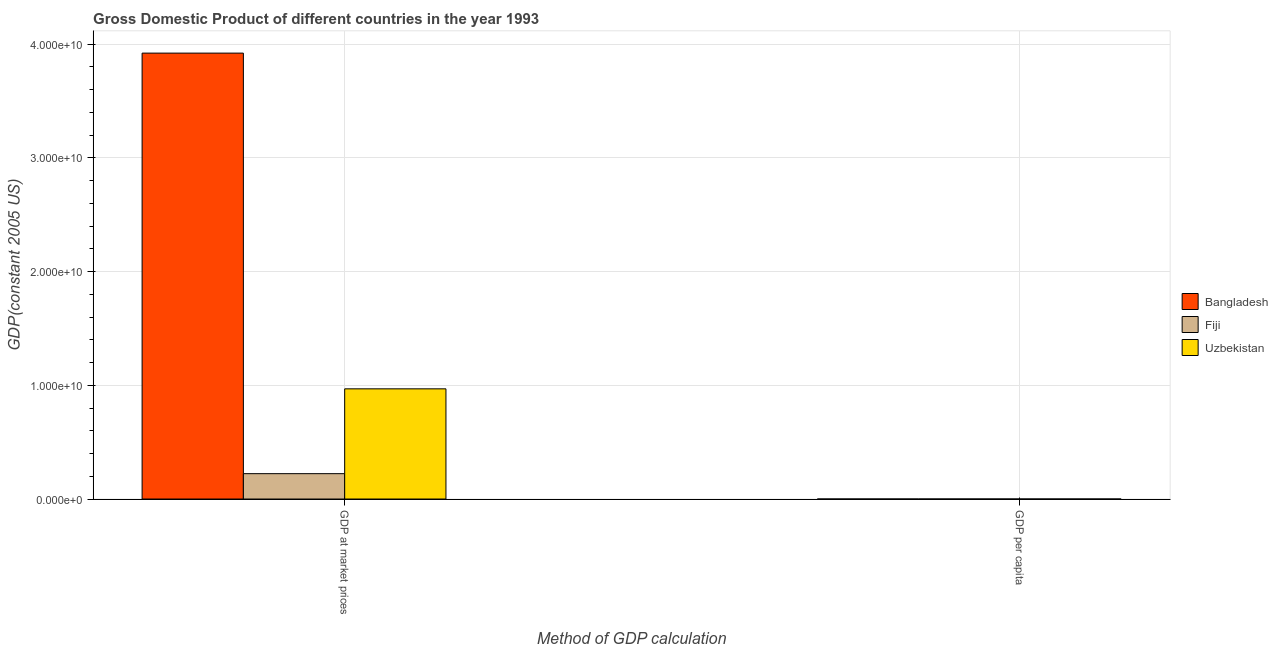How many groups of bars are there?
Your answer should be very brief. 2. How many bars are there on the 2nd tick from the left?
Your answer should be very brief. 3. What is the label of the 1st group of bars from the left?
Your answer should be very brief. GDP at market prices. What is the gdp at market prices in Uzbekistan?
Ensure brevity in your answer.  9.69e+09. Across all countries, what is the maximum gdp at market prices?
Give a very brief answer. 3.92e+1. Across all countries, what is the minimum gdp per capita?
Make the answer very short. 345.56. In which country was the gdp per capita maximum?
Make the answer very short. Fiji. In which country was the gdp at market prices minimum?
Ensure brevity in your answer.  Fiji. What is the total gdp per capita in the graph?
Make the answer very short. 3740.01. What is the difference between the gdp at market prices in Bangladesh and that in Fiji?
Offer a terse response. 3.70e+1. What is the difference between the gdp at market prices in Fiji and the gdp per capita in Uzbekistan?
Your answer should be compact. 2.23e+09. What is the average gdp at market prices per country?
Your response must be concise. 1.70e+1. What is the difference between the gdp at market prices and gdp per capita in Fiji?
Give a very brief answer. 2.23e+09. What is the ratio of the gdp per capita in Fiji to that in Bangladesh?
Provide a succinct answer. 8.55. Is the gdp at market prices in Bangladesh less than that in Fiji?
Your response must be concise. No. What does the 1st bar from the left in GDP at market prices represents?
Make the answer very short. Bangladesh. What does the 2nd bar from the right in GDP at market prices represents?
Keep it short and to the point. Fiji. How many bars are there?
Provide a short and direct response. 6. Does the graph contain any zero values?
Keep it short and to the point. No. How are the legend labels stacked?
Keep it short and to the point. Vertical. What is the title of the graph?
Offer a very short reply. Gross Domestic Product of different countries in the year 1993. Does "Ireland" appear as one of the legend labels in the graph?
Your answer should be compact. No. What is the label or title of the X-axis?
Offer a very short reply. Method of GDP calculation. What is the label or title of the Y-axis?
Offer a very short reply. GDP(constant 2005 US). What is the GDP(constant 2005 US) of Bangladesh in GDP at market prices?
Your answer should be very brief. 3.92e+1. What is the GDP(constant 2005 US) of Fiji in GDP at market prices?
Keep it short and to the point. 2.23e+09. What is the GDP(constant 2005 US) of Uzbekistan in GDP at market prices?
Provide a succinct answer. 9.69e+09. What is the GDP(constant 2005 US) in Bangladesh in GDP per capita?
Keep it short and to the point. 345.56. What is the GDP(constant 2005 US) in Fiji in GDP per capita?
Give a very brief answer. 2952.94. What is the GDP(constant 2005 US) of Uzbekistan in GDP per capita?
Your answer should be compact. 441.5. Across all Method of GDP calculation, what is the maximum GDP(constant 2005 US) of Bangladesh?
Your response must be concise. 3.92e+1. Across all Method of GDP calculation, what is the maximum GDP(constant 2005 US) in Fiji?
Offer a very short reply. 2.23e+09. Across all Method of GDP calculation, what is the maximum GDP(constant 2005 US) in Uzbekistan?
Your response must be concise. 9.69e+09. Across all Method of GDP calculation, what is the minimum GDP(constant 2005 US) of Bangladesh?
Your response must be concise. 345.56. Across all Method of GDP calculation, what is the minimum GDP(constant 2005 US) of Fiji?
Your answer should be very brief. 2952.94. Across all Method of GDP calculation, what is the minimum GDP(constant 2005 US) in Uzbekistan?
Ensure brevity in your answer.  441.5. What is the total GDP(constant 2005 US) of Bangladesh in the graph?
Your response must be concise. 3.92e+1. What is the total GDP(constant 2005 US) of Fiji in the graph?
Your response must be concise. 2.23e+09. What is the total GDP(constant 2005 US) of Uzbekistan in the graph?
Ensure brevity in your answer.  9.69e+09. What is the difference between the GDP(constant 2005 US) in Bangladesh in GDP at market prices and that in GDP per capita?
Offer a terse response. 3.92e+1. What is the difference between the GDP(constant 2005 US) of Fiji in GDP at market prices and that in GDP per capita?
Your answer should be compact. 2.23e+09. What is the difference between the GDP(constant 2005 US) of Uzbekistan in GDP at market prices and that in GDP per capita?
Ensure brevity in your answer.  9.69e+09. What is the difference between the GDP(constant 2005 US) of Bangladesh in GDP at market prices and the GDP(constant 2005 US) of Fiji in GDP per capita?
Keep it short and to the point. 3.92e+1. What is the difference between the GDP(constant 2005 US) in Bangladesh in GDP at market prices and the GDP(constant 2005 US) in Uzbekistan in GDP per capita?
Provide a short and direct response. 3.92e+1. What is the difference between the GDP(constant 2005 US) in Fiji in GDP at market prices and the GDP(constant 2005 US) in Uzbekistan in GDP per capita?
Offer a terse response. 2.23e+09. What is the average GDP(constant 2005 US) in Bangladesh per Method of GDP calculation?
Make the answer very short. 1.96e+1. What is the average GDP(constant 2005 US) in Fiji per Method of GDP calculation?
Keep it short and to the point. 1.11e+09. What is the average GDP(constant 2005 US) of Uzbekistan per Method of GDP calculation?
Offer a very short reply. 4.84e+09. What is the difference between the GDP(constant 2005 US) in Bangladesh and GDP(constant 2005 US) in Fiji in GDP at market prices?
Your answer should be compact. 3.70e+1. What is the difference between the GDP(constant 2005 US) of Bangladesh and GDP(constant 2005 US) of Uzbekistan in GDP at market prices?
Offer a very short reply. 2.95e+1. What is the difference between the GDP(constant 2005 US) in Fiji and GDP(constant 2005 US) in Uzbekistan in GDP at market prices?
Your response must be concise. -7.46e+09. What is the difference between the GDP(constant 2005 US) of Bangladesh and GDP(constant 2005 US) of Fiji in GDP per capita?
Your answer should be very brief. -2607.38. What is the difference between the GDP(constant 2005 US) of Bangladesh and GDP(constant 2005 US) of Uzbekistan in GDP per capita?
Make the answer very short. -95.94. What is the difference between the GDP(constant 2005 US) of Fiji and GDP(constant 2005 US) of Uzbekistan in GDP per capita?
Your answer should be compact. 2511.44. What is the ratio of the GDP(constant 2005 US) of Bangladesh in GDP at market prices to that in GDP per capita?
Your response must be concise. 1.13e+08. What is the ratio of the GDP(constant 2005 US) in Fiji in GDP at market prices to that in GDP per capita?
Keep it short and to the point. 7.55e+05. What is the ratio of the GDP(constant 2005 US) in Uzbekistan in GDP at market prices to that in GDP per capita?
Keep it short and to the point. 2.19e+07. What is the difference between the highest and the second highest GDP(constant 2005 US) of Bangladesh?
Your answer should be compact. 3.92e+1. What is the difference between the highest and the second highest GDP(constant 2005 US) in Fiji?
Provide a short and direct response. 2.23e+09. What is the difference between the highest and the second highest GDP(constant 2005 US) of Uzbekistan?
Your answer should be compact. 9.69e+09. What is the difference between the highest and the lowest GDP(constant 2005 US) of Bangladesh?
Offer a very short reply. 3.92e+1. What is the difference between the highest and the lowest GDP(constant 2005 US) in Fiji?
Keep it short and to the point. 2.23e+09. What is the difference between the highest and the lowest GDP(constant 2005 US) of Uzbekistan?
Your response must be concise. 9.69e+09. 